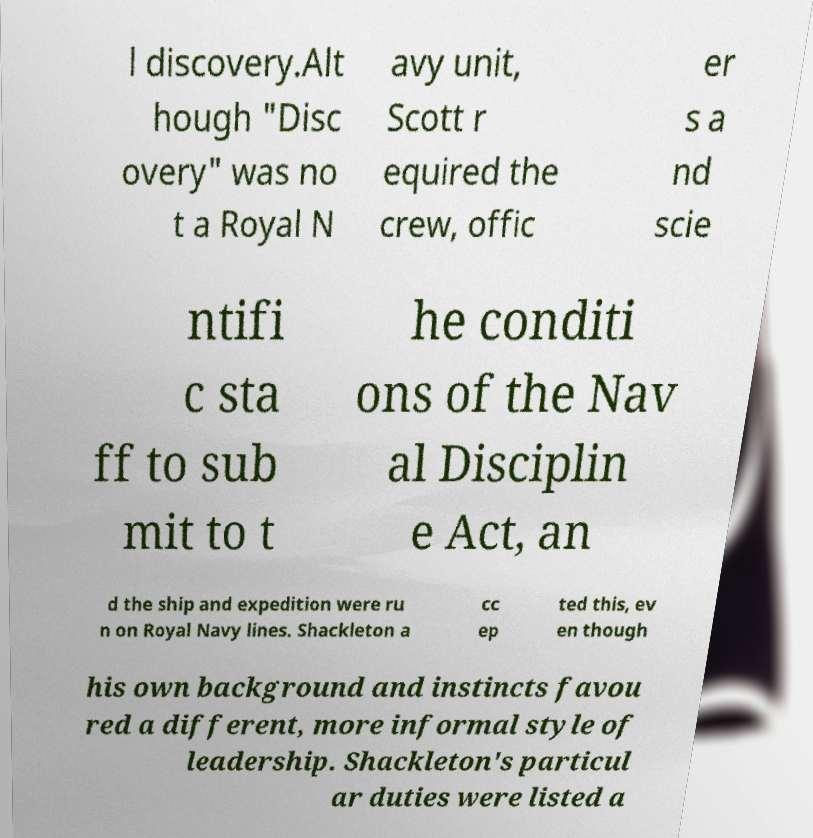Can you accurately transcribe the text from the provided image for me? l discovery.Alt hough "Disc overy" was no t a Royal N avy unit, Scott r equired the crew, offic er s a nd scie ntifi c sta ff to sub mit to t he conditi ons of the Nav al Disciplin e Act, an d the ship and expedition were ru n on Royal Navy lines. Shackleton a cc ep ted this, ev en though his own background and instincts favou red a different, more informal style of leadership. Shackleton's particul ar duties were listed a 